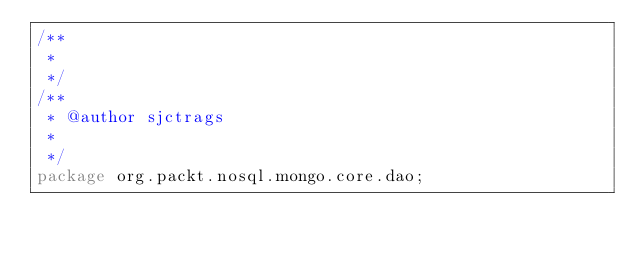<code> <loc_0><loc_0><loc_500><loc_500><_Java_>/**
 * 
 */
/**
 * @author sjctrags
 *
 */
package org.packt.nosql.mongo.core.dao;</code> 